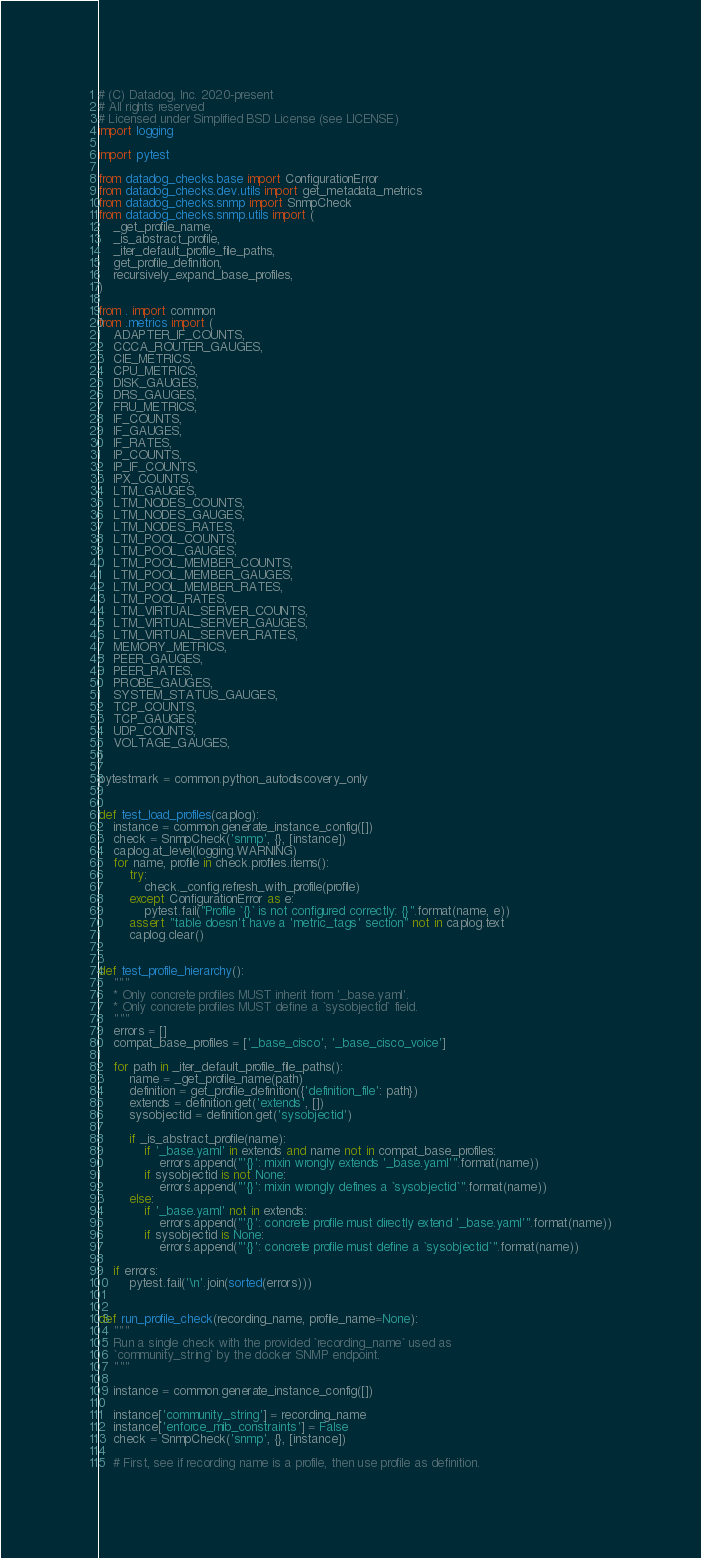<code> <loc_0><loc_0><loc_500><loc_500><_Python_># (C) Datadog, Inc. 2020-present
# All rights reserved
# Licensed under Simplified BSD License (see LICENSE)
import logging

import pytest

from datadog_checks.base import ConfigurationError
from datadog_checks.dev.utils import get_metadata_metrics
from datadog_checks.snmp import SnmpCheck
from datadog_checks.snmp.utils import (
    _get_profile_name,
    _is_abstract_profile,
    _iter_default_profile_file_paths,
    get_profile_definition,
    recursively_expand_base_profiles,
)

from . import common
from .metrics import (
    ADAPTER_IF_COUNTS,
    CCCA_ROUTER_GAUGES,
    CIE_METRICS,
    CPU_METRICS,
    DISK_GAUGES,
    DRS_GAUGES,
    FRU_METRICS,
    IF_COUNTS,
    IF_GAUGES,
    IF_RATES,
    IP_COUNTS,
    IP_IF_COUNTS,
    IPX_COUNTS,
    LTM_GAUGES,
    LTM_NODES_COUNTS,
    LTM_NODES_GAUGES,
    LTM_NODES_RATES,
    LTM_POOL_COUNTS,
    LTM_POOL_GAUGES,
    LTM_POOL_MEMBER_COUNTS,
    LTM_POOL_MEMBER_GAUGES,
    LTM_POOL_MEMBER_RATES,
    LTM_POOL_RATES,
    LTM_VIRTUAL_SERVER_COUNTS,
    LTM_VIRTUAL_SERVER_GAUGES,
    LTM_VIRTUAL_SERVER_RATES,
    MEMORY_METRICS,
    PEER_GAUGES,
    PEER_RATES,
    PROBE_GAUGES,
    SYSTEM_STATUS_GAUGES,
    TCP_COUNTS,
    TCP_GAUGES,
    UDP_COUNTS,
    VOLTAGE_GAUGES,
)

pytestmark = common.python_autodiscovery_only


def test_load_profiles(caplog):
    instance = common.generate_instance_config([])
    check = SnmpCheck('snmp', {}, [instance])
    caplog.at_level(logging.WARNING)
    for name, profile in check.profiles.items():
        try:
            check._config.refresh_with_profile(profile)
        except ConfigurationError as e:
            pytest.fail("Profile `{}` is not configured correctly: {}".format(name, e))
        assert "table doesn't have a 'metric_tags' section" not in caplog.text
        caplog.clear()


def test_profile_hierarchy():
    """
    * Only concrete profiles MUST inherit from '_base.yaml'.
    * Only concrete profiles MUST define a `sysobjectid` field.
    """
    errors = []
    compat_base_profiles = ['_base_cisco', '_base_cisco_voice']

    for path in _iter_default_profile_file_paths():
        name = _get_profile_name(path)
        definition = get_profile_definition({'definition_file': path})
        extends = definition.get('extends', [])
        sysobjectid = definition.get('sysobjectid')

        if _is_abstract_profile(name):
            if '_base.yaml' in extends and name not in compat_base_profiles:
                errors.append("'{}': mixin wrongly extends '_base.yaml'".format(name))
            if sysobjectid is not None:
                errors.append("'{}': mixin wrongly defines a `sysobjectid`".format(name))
        else:
            if '_base.yaml' not in extends:
                errors.append("'{}': concrete profile must directly extend '_base.yaml'".format(name))
            if sysobjectid is None:
                errors.append("'{}': concrete profile must define a `sysobjectid`".format(name))

    if errors:
        pytest.fail('\n'.join(sorted(errors)))


def run_profile_check(recording_name, profile_name=None):
    """
    Run a single check with the provided `recording_name` used as
    `community_string` by the docker SNMP endpoint.
    """

    instance = common.generate_instance_config([])

    instance['community_string'] = recording_name
    instance['enforce_mib_constraints'] = False
    check = SnmpCheck('snmp', {}, [instance])

    # First, see if recording name is a profile, then use profile as definition.</code> 